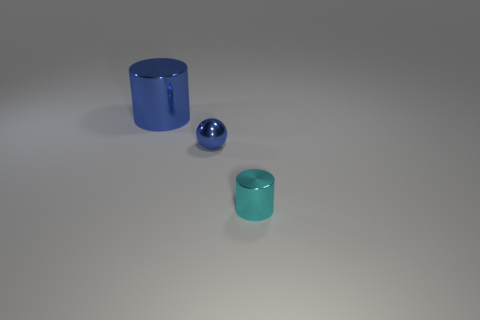Add 2 green blocks. How many objects exist? 5 Subtract all balls. How many objects are left? 2 Add 1 cyan matte objects. How many cyan matte objects exist? 1 Subtract 0 brown cylinders. How many objects are left? 3 Subtract all blue shiny spheres. Subtract all blue objects. How many objects are left? 0 Add 3 large shiny cylinders. How many large shiny cylinders are left? 4 